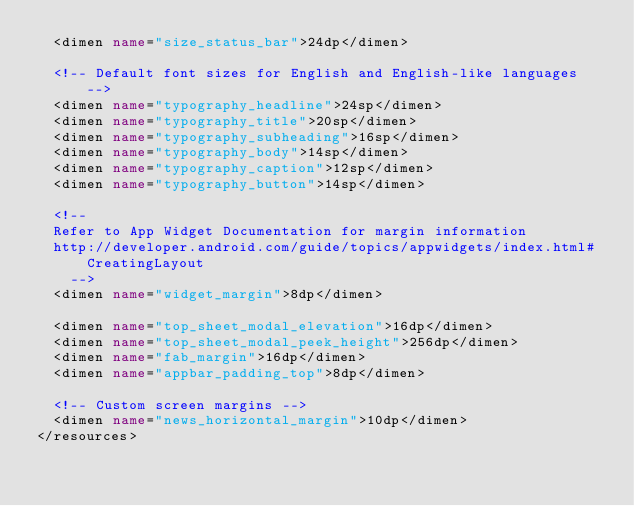<code> <loc_0><loc_0><loc_500><loc_500><_XML_>	<dimen name="size_status_bar">24dp</dimen>

	<!-- Default font sizes for English and English-like languages -->
	<dimen name="typography_headline">24sp</dimen>
	<dimen name="typography_title">20sp</dimen>
	<dimen name="typography_subheading">16sp</dimen>
	<dimen name="typography_body">14sp</dimen>
	<dimen name="typography_caption">12sp</dimen>
	<dimen name="typography_button">14sp</dimen>

	<!--
	Refer to App Widget Documentation for margin information
	http://developer.android.com/guide/topics/appwidgets/index.html#CreatingLayout
    -->
	<dimen name="widget_margin">8dp</dimen>

	<dimen name="top_sheet_modal_elevation">16dp</dimen>
	<dimen name="top_sheet_modal_peek_height">256dp</dimen>
	<dimen name="fab_margin">16dp</dimen>
	<dimen name="appbar_padding_top">8dp</dimen>

	<!-- Custom screen margins -->
	<dimen name="news_horizontal_margin">10dp</dimen>
</resources>
</code> 